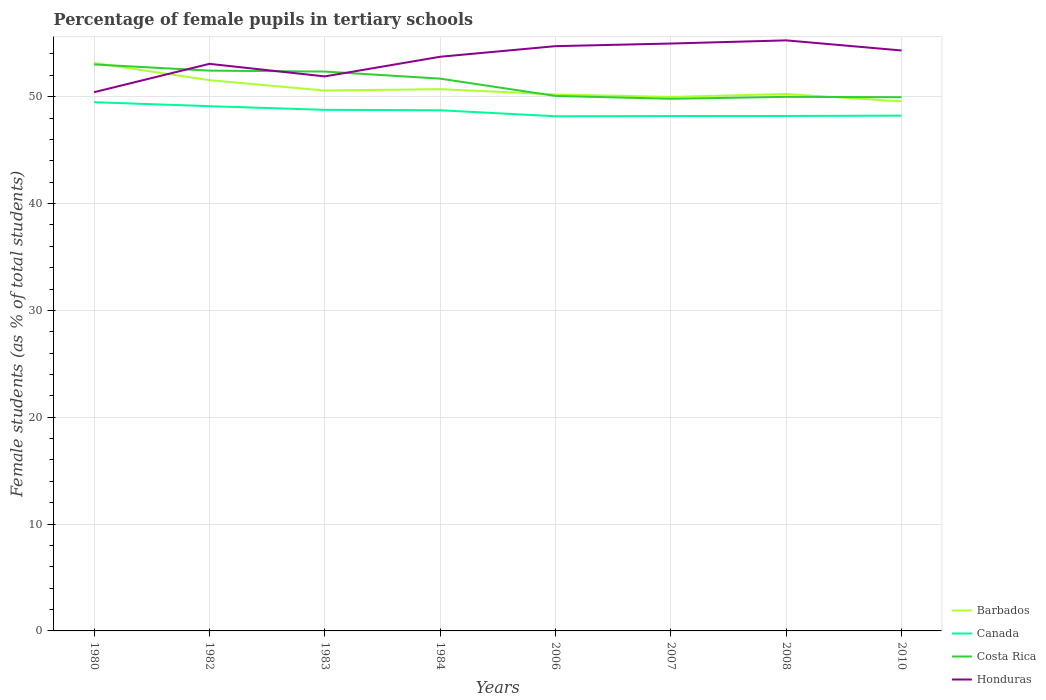How many different coloured lines are there?
Provide a short and direct response. 4. Across all years, what is the maximum percentage of female pupils in tertiary schools in Honduras?
Your answer should be compact. 50.42. In which year was the percentage of female pupils in tertiary schools in Canada maximum?
Keep it short and to the point. 2006. What is the total percentage of female pupils in tertiary schools in Honduras in the graph?
Your answer should be compact. -4.56. What is the difference between the highest and the second highest percentage of female pupils in tertiary schools in Honduras?
Ensure brevity in your answer.  4.85. What is the difference between two consecutive major ticks on the Y-axis?
Provide a succinct answer. 10. Does the graph contain any zero values?
Offer a very short reply. No. Where does the legend appear in the graph?
Make the answer very short. Bottom right. What is the title of the graph?
Your response must be concise. Percentage of female pupils in tertiary schools. What is the label or title of the Y-axis?
Give a very brief answer. Female students (as % of total students). What is the Female students (as % of total students) in Barbados in 1980?
Offer a very short reply. 53.16. What is the Female students (as % of total students) in Canada in 1980?
Provide a succinct answer. 49.48. What is the Female students (as % of total students) of Costa Rica in 1980?
Your response must be concise. 53.02. What is the Female students (as % of total students) in Honduras in 1980?
Keep it short and to the point. 50.42. What is the Female students (as % of total students) in Barbados in 1982?
Your response must be concise. 51.55. What is the Female students (as % of total students) in Canada in 1982?
Your answer should be very brief. 49.11. What is the Female students (as % of total students) of Costa Rica in 1982?
Your response must be concise. 52.44. What is the Female students (as % of total students) of Honduras in 1982?
Ensure brevity in your answer.  53.07. What is the Female students (as % of total students) in Barbados in 1983?
Give a very brief answer. 50.58. What is the Female students (as % of total students) of Canada in 1983?
Your response must be concise. 48.77. What is the Female students (as % of total students) of Costa Rica in 1983?
Offer a very short reply. 52.35. What is the Female students (as % of total students) of Honduras in 1983?
Offer a very short reply. 51.9. What is the Female students (as % of total students) in Barbados in 1984?
Your answer should be very brief. 50.71. What is the Female students (as % of total students) of Canada in 1984?
Make the answer very short. 48.73. What is the Female students (as % of total students) of Costa Rica in 1984?
Ensure brevity in your answer.  51.69. What is the Female students (as % of total students) in Honduras in 1984?
Your answer should be compact. 53.74. What is the Female students (as % of total students) of Barbados in 2006?
Your answer should be compact. 50.21. What is the Female students (as % of total students) of Canada in 2006?
Provide a succinct answer. 48.17. What is the Female students (as % of total students) of Costa Rica in 2006?
Offer a very short reply. 50.07. What is the Female students (as % of total students) of Honduras in 2006?
Provide a short and direct response. 54.73. What is the Female students (as % of total students) of Barbados in 2007?
Your answer should be compact. 49.98. What is the Female students (as % of total students) of Canada in 2007?
Give a very brief answer. 48.19. What is the Female students (as % of total students) of Costa Rica in 2007?
Offer a terse response. 49.8. What is the Female students (as % of total students) in Honduras in 2007?
Provide a short and direct response. 54.98. What is the Female students (as % of total students) in Barbados in 2008?
Keep it short and to the point. 50.25. What is the Female students (as % of total students) of Canada in 2008?
Your response must be concise. 48.2. What is the Female students (as % of total students) of Costa Rica in 2008?
Give a very brief answer. 49.99. What is the Female students (as % of total students) in Honduras in 2008?
Provide a short and direct response. 55.27. What is the Female students (as % of total students) of Barbados in 2010?
Your answer should be very brief. 49.56. What is the Female students (as % of total students) of Canada in 2010?
Provide a succinct answer. 48.23. What is the Female students (as % of total students) of Costa Rica in 2010?
Keep it short and to the point. 49.95. What is the Female students (as % of total students) in Honduras in 2010?
Ensure brevity in your answer.  54.33. Across all years, what is the maximum Female students (as % of total students) of Barbados?
Offer a terse response. 53.16. Across all years, what is the maximum Female students (as % of total students) in Canada?
Your response must be concise. 49.48. Across all years, what is the maximum Female students (as % of total students) of Costa Rica?
Your answer should be very brief. 53.02. Across all years, what is the maximum Female students (as % of total students) of Honduras?
Your answer should be very brief. 55.27. Across all years, what is the minimum Female students (as % of total students) in Barbados?
Offer a terse response. 49.56. Across all years, what is the minimum Female students (as % of total students) of Canada?
Your response must be concise. 48.17. Across all years, what is the minimum Female students (as % of total students) in Costa Rica?
Your answer should be compact. 49.8. Across all years, what is the minimum Female students (as % of total students) in Honduras?
Your response must be concise. 50.42. What is the total Female students (as % of total students) in Barbados in the graph?
Give a very brief answer. 405.99. What is the total Female students (as % of total students) of Canada in the graph?
Keep it short and to the point. 388.88. What is the total Female students (as % of total students) of Costa Rica in the graph?
Provide a succinct answer. 409.32. What is the total Female students (as % of total students) of Honduras in the graph?
Offer a terse response. 428.44. What is the difference between the Female students (as % of total students) of Barbados in 1980 and that in 1982?
Give a very brief answer. 1.61. What is the difference between the Female students (as % of total students) in Canada in 1980 and that in 1982?
Your response must be concise. 0.37. What is the difference between the Female students (as % of total students) in Costa Rica in 1980 and that in 1982?
Offer a terse response. 0.58. What is the difference between the Female students (as % of total students) in Honduras in 1980 and that in 1982?
Your answer should be compact. -2.65. What is the difference between the Female students (as % of total students) in Barbados in 1980 and that in 1983?
Offer a terse response. 2.58. What is the difference between the Female students (as % of total students) of Canada in 1980 and that in 1983?
Your answer should be very brief. 0.71. What is the difference between the Female students (as % of total students) in Costa Rica in 1980 and that in 1983?
Offer a very short reply. 0.67. What is the difference between the Female students (as % of total students) in Honduras in 1980 and that in 1983?
Your answer should be very brief. -1.48. What is the difference between the Female students (as % of total students) of Barbados in 1980 and that in 1984?
Provide a succinct answer. 2.45. What is the difference between the Female students (as % of total students) of Canada in 1980 and that in 1984?
Make the answer very short. 0.76. What is the difference between the Female students (as % of total students) of Costa Rica in 1980 and that in 1984?
Your answer should be compact. 1.33. What is the difference between the Female students (as % of total students) in Honduras in 1980 and that in 1984?
Offer a very short reply. -3.32. What is the difference between the Female students (as % of total students) of Barbados in 1980 and that in 2006?
Make the answer very short. 2.95. What is the difference between the Female students (as % of total students) in Canada in 1980 and that in 2006?
Your response must be concise. 1.32. What is the difference between the Female students (as % of total students) of Costa Rica in 1980 and that in 2006?
Offer a very short reply. 2.95. What is the difference between the Female students (as % of total students) of Honduras in 1980 and that in 2006?
Your response must be concise. -4.31. What is the difference between the Female students (as % of total students) of Barbados in 1980 and that in 2007?
Your response must be concise. 3.18. What is the difference between the Female students (as % of total students) in Canada in 1980 and that in 2007?
Make the answer very short. 1.3. What is the difference between the Female students (as % of total students) of Costa Rica in 1980 and that in 2007?
Ensure brevity in your answer.  3.21. What is the difference between the Female students (as % of total students) in Honduras in 1980 and that in 2007?
Provide a short and direct response. -4.56. What is the difference between the Female students (as % of total students) in Barbados in 1980 and that in 2008?
Provide a succinct answer. 2.9. What is the difference between the Female students (as % of total students) of Canada in 1980 and that in 2008?
Your answer should be very brief. 1.29. What is the difference between the Female students (as % of total students) of Costa Rica in 1980 and that in 2008?
Provide a succinct answer. 3.03. What is the difference between the Female students (as % of total students) of Honduras in 1980 and that in 2008?
Keep it short and to the point. -4.85. What is the difference between the Female students (as % of total students) of Barbados in 1980 and that in 2010?
Your answer should be very brief. 3.59. What is the difference between the Female students (as % of total students) in Canada in 1980 and that in 2010?
Your answer should be compact. 1.26. What is the difference between the Female students (as % of total students) in Costa Rica in 1980 and that in 2010?
Ensure brevity in your answer.  3.07. What is the difference between the Female students (as % of total students) in Honduras in 1980 and that in 2010?
Offer a terse response. -3.9. What is the difference between the Female students (as % of total students) of Canada in 1982 and that in 1983?
Your answer should be very brief. 0.34. What is the difference between the Female students (as % of total students) in Costa Rica in 1982 and that in 1983?
Offer a terse response. 0.09. What is the difference between the Female students (as % of total students) in Honduras in 1982 and that in 1983?
Provide a short and direct response. 1.18. What is the difference between the Female students (as % of total students) of Barbados in 1982 and that in 1984?
Your answer should be compact. 0.84. What is the difference between the Female students (as % of total students) of Canada in 1982 and that in 1984?
Offer a terse response. 0.38. What is the difference between the Female students (as % of total students) in Costa Rica in 1982 and that in 1984?
Offer a terse response. 0.75. What is the difference between the Female students (as % of total students) of Honduras in 1982 and that in 1984?
Offer a very short reply. -0.66. What is the difference between the Female students (as % of total students) in Barbados in 1982 and that in 2006?
Your answer should be compact. 1.34. What is the difference between the Female students (as % of total students) of Canada in 1982 and that in 2006?
Make the answer very short. 0.94. What is the difference between the Female students (as % of total students) of Costa Rica in 1982 and that in 2006?
Your answer should be compact. 2.37. What is the difference between the Female students (as % of total students) in Honduras in 1982 and that in 2006?
Keep it short and to the point. -1.66. What is the difference between the Female students (as % of total students) in Barbados in 1982 and that in 2007?
Ensure brevity in your answer.  1.57. What is the difference between the Female students (as % of total students) of Canada in 1982 and that in 2007?
Your answer should be compact. 0.92. What is the difference between the Female students (as % of total students) of Costa Rica in 1982 and that in 2007?
Your response must be concise. 2.64. What is the difference between the Female students (as % of total students) of Honduras in 1982 and that in 2007?
Ensure brevity in your answer.  -1.9. What is the difference between the Female students (as % of total students) in Barbados in 1982 and that in 2008?
Offer a terse response. 1.3. What is the difference between the Female students (as % of total students) of Canada in 1982 and that in 2008?
Offer a very short reply. 0.91. What is the difference between the Female students (as % of total students) in Costa Rica in 1982 and that in 2008?
Your answer should be very brief. 2.45. What is the difference between the Female students (as % of total students) of Honduras in 1982 and that in 2008?
Offer a very short reply. -2.2. What is the difference between the Female students (as % of total students) in Barbados in 1982 and that in 2010?
Make the answer very short. 1.99. What is the difference between the Female students (as % of total students) of Canada in 1982 and that in 2010?
Offer a terse response. 0.88. What is the difference between the Female students (as % of total students) of Costa Rica in 1982 and that in 2010?
Provide a short and direct response. 2.49. What is the difference between the Female students (as % of total students) of Honduras in 1982 and that in 2010?
Your answer should be compact. -1.25. What is the difference between the Female students (as % of total students) of Barbados in 1983 and that in 1984?
Your answer should be compact. -0.13. What is the difference between the Female students (as % of total students) of Canada in 1983 and that in 1984?
Your response must be concise. 0.04. What is the difference between the Female students (as % of total students) in Costa Rica in 1983 and that in 1984?
Give a very brief answer. 0.66. What is the difference between the Female students (as % of total students) in Honduras in 1983 and that in 1984?
Provide a short and direct response. -1.84. What is the difference between the Female students (as % of total students) in Barbados in 1983 and that in 2006?
Your answer should be compact. 0.37. What is the difference between the Female students (as % of total students) of Canada in 1983 and that in 2006?
Make the answer very short. 0.6. What is the difference between the Female students (as % of total students) of Costa Rica in 1983 and that in 2006?
Provide a short and direct response. 2.28. What is the difference between the Female students (as % of total students) of Honduras in 1983 and that in 2006?
Provide a succinct answer. -2.83. What is the difference between the Female students (as % of total students) in Barbados in 1983 and that in 2007?
Ensure brevity in your answer.  0.6. What is the difference between the Female students (as % of total students) of Canada in 1983 and that in 2007?
Offer a terse response. 0.58. What is the difference between the Female students (as % of total students) in Costa Rica in 1983 and that in 2007?
Keep it short and to the point. 2.55. What is the difference between the Female students (as % of total students) in Honduras in 1983 and that in 2007?
Make the answer very short. -3.08. What is the difference between the Female students (as % of total students) of Barbados in 1983 and that in 2008?
Ensure brevity in your answer.  0.32. What is the difference between the Female students (as % of total students) of Canada in 1983 and that in 2008?
Provide a succinct answer. 0.57. What is the difference between the Female students (as % of total students) in Costa Rica in 1983 and that in 2008?
Give a very brief answer. 2.37. What is the difference between the Female students (as % of total students) of Honduras in 1983 and that in 2008?
Offer a very short reply. -3.37. What is the difference between the Female students (as % of total students) of Barbados in 1983 and that in 2010?
Your response must be concise. 1.01. What is the difference between the Female students (as % of total students) in Canada in 1983 and that in 2010?
Provide a short and direct response. 0.54. What is the difference between the Female students (as % of total students) in Costa Rica in 1983 and that in 2010?
Your answer should be very brief. 2.4. What is the difference between the Female students (as % of total students) of Honduras in 1983 and that in 2010?
Give a very brief answer. -2.43. What is the difference between the Female students (as % of total students) of Barbados in 1984 and that in 2006?
Ensure brevity in your answer.  0.5. What is the difference between the Female students (as % of total students) in Canada in 1984 and that in 2006?
Keep it short and to the point. 0.56. What is the difference between the Female students (as % of total students) of Costa Rica in 1984 and that in 2006?
Your response must be concise. 1.62. What is the difference between the Female students (as % of total students) in Honduras in 1984 and that in 2006?
Ensure brevity in your answer.  -0.99. What is the difference between the Female students (as % of total students) in Barbados in 1984 and that in 2007?
Your response must be concise. 0.73. What is the difference between the Female students (as % of total students) in Canada in 1984 and that in 2007?
Provide a succinct answer. 0.54. What is the difference between the Female students (as % of total students) of Costa Rica in 1984 and that in 2007?
Offer a terse response. 1.89. What is the difference between the Female students (as % of total students) in Honduras in 1984 and that in 2007?
Provide a short and direct response. -1.24. What is the difference between the Female students (as % of total students) in Barbados in 1984 and that in 2008?
Your answer should be very brief. 0.45. What is the difference between the Female students (as % of total students) in Canada in 1984 and that in 2008?
Make the answer very short. 0.53. What is the difference between the Female students (as % of total students) in Costa Rica in 1984 and that in 2008?
Give a very brief answer. 1.7. What is the difference between the Female students (as % of total students) of Honduras in 1984 and that in 2008?
Keep it short and to the point. -1.53. What is the difference between the Female students (as % of total students) in Barbados in 1984 and that in 2010?
Provide a succinct answer. 1.14. What is the difference between the Female students (as % of total students) in Canada in 1984 and that in 2010?
Provide a short and direct response. 0.5. What is the difference between the Female students (as % of total students) in Costa Rica in 1984 and that in 2010?
Your answer should be very brief. 1.74. What is the difference between the Female students (as % of total students) in Honduras in 1984 and that in 2010?
Your response must be concise. -0.59. What is the difference between the Female students (as % of total students) in Barbados in 2006 and that in 2007?
Keep it short and to the point. 0.23. What is the difference between the Female students (as % of total students) of Canada in 2006 and that in 2007?
Offer a very short reply. -0.02. What is the difference between the Female students (as % of total students) in Costa Rica in 2006 and that in 2007?
Your answer should be very brief. 0.27. What is the difference between the Female students (as % of total students) in Honduras in 2006 and that in 2007?
Give a very brief answer. -0.25. What is the difference between the Female students (as % of total students) of Barbados in 2006 and that in 2008?
Your response must be concise. -0.04. What is the difference between the Female students (as % of total students) of Canada in 2006 and that in 2008?
Give a very brief answer. -0.03. What is the difference between the Female students (as % of total students) in Costa Rica in 2006 and that in 2008?
Provide a succinct answer. 0.09. What is the difference between the Female students (as % of total students) in Honduras in 2006 and that in 2008?
Provide a succinct answer. -0.54. What is the difference between the Female students (as % of total students) of Barbados in 2006 and that in 2010?
Keep it short and to the point. 0.65. What is the difference between the Female students (as % of total students) of Canada in 2006 and that in 2010?
Your answer should be very brief. -0.06. What is the difference between the Female students (as % of total students) in Costa Rica in 2006 and that in 2010?
Keep it short and to the point. 0.12. What is the difference between the Female students (as % of total students) in Honduras in 2006 and that in 2010?
Provide a short and direct response. 0.4. What is the difference between the Female students (as % of total students) of Barbados in 2007 and that in 2008?
Keep it short and to the point. -0.28. What is the difference between the Female students (as % of total students) in Canada in 2007 and that in 2008?
Offer a terse response. -0.01. What is the difference between the Female students (as % of total students) of Costa Rica in 2007 and that in 2008?
Provide a short and direct response. -0.18. What is the difference between the Female students (as % of total students) of Honduras in 2007 and that in 2008?
Provide a short and direct response. -0.3. What is the difference between the Female students (as % of total students) of Barbados in 2007 and that in 2010?
Offer a very short reply. 0.42. What is the difference between the Female students (as % of total students) of Canada in 2007 and that in 2010?
Your answer should be compact. -0.04. What is the difference between the Female students (as % of total students) in Costa Rica in 2007 and that in 2010?
Give a very brief answer. -0.15. What is the difference between the Female students (as % of total students) of Honduras in 2007 and that in 2010?
Your response must be concise. 0.65. What is the difference between the Female students (as % of total students) of Barbados in 2008 and that in 2010?
Provide a short and direct response. 0.69. What is the difference between the Female students (as % of total students) of Canada in 2008 and that in 2010?
Make the answer very short. -0.03. What is the difference between the Female students (as % of total students) of Costa Rica in 2008 and that in 2010?
Offer a very short reply. 0.03. What is the difference between the Female students (as % of total students) in Honduras in 2008 and that in 2010?
Your answer should be very brief. 0.95. What is the difference between the Female students (as % of total students) in Barbados in 1980 and the Female students (as % of total students) in Canada in 1982?
Ensure brevity in your answer.  4.04. What is the difference between the Female students (as % of total students) in Barbados in 1980 and the Female students (as % of total students) in Costa Rica in 1982?
Ensure brevity in your answer.  0.72. What is the difference between the Female students (as % of total students) in Barbados in 1980 and the Female students (as % of total students) in Honduras in 1982?
Make the answer very short. 0.08. What is the difference between the Female students (as % of total students) of Canada in 1980 and the Female students (as % of total students) of Costa Rica in 1982?
Offer a very short reply. -2.96. What is the difference between the Female students (as % of total students) in Canada in 1980 and the Female students (as % of total students) in Honduras in 1982?
Ensure brevity in your answer.  -3.59. What is the difference between the Female students (as % of total students) of Costa Rica in 1980 and the Female students (as % of total students) of Honduras in 1982?
Your answer should be very brief. -0.06. What is the difference between the Female students (as % of total students) of Barbados in 1980 and the Female students (as % of total students) of Canada in 1983?
Provide a short and direct response. 4.38. What is the difference between the Female students (as % of total students) in Barbados in 1980 and the Female students (as % of total students) in Costa Rica in 1983?
Ensure brevity in your answer.  0.8. What is the difference between the Female students (as % of total students) of Barbados in 1980 and the Female students (as % of total students) of Honduras in 1983?
Make the answer very short. 1.26. What is the difference between the Female students (as % of total students) of Canada in 1980 and the Female students (as % of total students) of Costa Rica in 1983?
Provide a short and direct response. -2.87. What is the difference between the Female students (as % of total students) in Canada in 1980 and the Female students (as % of total students) in Honduras in 1983?
Your response must be concise. -2.41. What is the difference between the Female students (as % of total students) in Costa Rica in 1980 and the Female students (as % of total students) in Honduras in 1983?
Keep it short and to the point. 1.12. What is the difference between the Female students (as % of total students) in Barbados in 1980 and the Female students (as % of total students) in Canada in 1984?
Ensure brevity in your answer.  4.43. What is the difference between the Female students (as % of total students) in Barbados in 1980 and the Female students (as % of total students) in Costa Rica in 1984?
Give a very brief answer. 1.47. What is the difference between the Female students (as % of total students) in Barbados in 1980 and the Female students (as % of total students) in Honduras in 1984?
Provide a succinct answer. -0.58. What is the difference between the Female students (as % of total students) in Canada in 1980 and the Female students (as % of total students) in Costa Rica in 1984?
Your answer should be very brief. -2.21. What is the difference between the Female students (as % of total students) in Canada in 1980 and the Female students (as % of total students) in Honduras in 1984?
Ensure brevity in your answer.  -4.25. What is the difference between the Female students (as % of total students) of Costa Rica in 1980 and the Female students (as % of total students) of Honduras in 1984?
Offer a very short reply. -0.72. What is the difference between the Female students (as % of total students) of Barbados in 1980 and the Female students (as % of total students) of Canada in 2006?
Your answer should be compact. 4.99. What is the difference between the Female students (as % of total students) of Barbados in 1980 and the Female students (as % of total students) of Costa Rica in 2006?
Your answer should be compact. 3.08. What is the difference between the Female students (as % of total students) of Barbados in 1980 and the Female students (as % of total students) of Honduras in 2006?
Make the answer very short. -1.57. What is the difference between the Female students (as % of total students) in Canada in 1980 and the Female students (as % of total students) in Costa Rica in 2006?
Offer a terse response. -0.59. What is the difference between the Female students (as % of total students) of Canada in 1980 and the Female students (as % of total students) of Honduras in 2006?
Offer a very short reply. -5.25. What is the difference between the Female students (as % of total students) in Costa Rica in 1980 and the Female students (as % of total students) in Honduras in 2006?
Make the answer very short. -1.71. What is the difference between the Female students (as % of total students) of Barbados in 1980 and the Female students (as % of total students) of Canada in 2007?
Offer a very short reply. 4.97. What is the difference between the Female students (as % of total students) of Barbados in 1980 and the Female students (as % of total students) of Costa Rica in 2007?
Make the answer very short. 3.35. What is the difference between the Female students (as % of total students) of Barbados in 1980 and the Female students (as % of total students) of Honduras in 2007?
Provide a short and direct response. -1.82. What is the difference between the Female students (as % of total students) of Canada in 1980 and the Female students (as % of total students) of Costa Rica in 2007?
Make the answer very short. -0.32. What is the difference between the Female students (as % of total students) in Canada in 1980 and the Female students (as % of total students) in Honduras in 2007?
Your answer should be compact. -5.49. What is the difference between the Female students (as % of total students) in Costa Rica in 1980 and the Female students (as % of total students) in Honduras in 2007?
Your response must be concise. -1.96. What is the difference between the Female students (as % of total students) in Barbados in 1980 and the Female students (as % of total students) in Canada in 2008?
Offer a terse response. 4.96. What is the difference between the Female students (as % of total students) of Barbados in 1980 and the Female students (as % of total students) of Costa Rica in 2008?
Make the answer very short. 3.17. What is the difference between the Female students (as % of total students) of Barbados in 1980 and the Female students (as % of total students) of Honduras in 2008?
Offer a terse response. -2.12. What is the difference between the Female students (as % of total students) of Canada in 1980 and the Female students (as % of total students) of Costa Rica in 2008?
Ensure brevity in your answer.  -0.5. What is the difference between the Female students (as % of total students) of Canada in 1980 and the Female students (as % of total students) of Honduras in 2008?
Make the answer very short. -5.79. What is the difference between the Female students (as % of total students) of Costa Rica in 1980 and the Female students (as % of total students) of Honduras in 2008?
Provide a short and direct response. -2.25. What is the difference between the Female students (as % of total students) of Barbados in 1980 and the Female students (as % of total students) of Canada in 2010?
Offer a very short reply. 4.93. What is the difference between the Female students (as % of total students) in Barbados in 1980 and the Female students (as % of total students) in Costa Rica in 2010?
Offer a terse response. 3.2. What is the difference between the Female students (as % of total students) in Barbados in 1980 and the Female students (as % of total students) in Honduras in 2010?
Make the answer very short. -1.17. What is the difference between the Female students (as % of total students) of Canada in 1980 and the Female students (as % of total students) of Costa Rica in 2010?
Your answer should be compact. -0.47. What is the difference between the Female students (as % of total students) in Canada in 1980 and the Female students (as % of total students) in Honduras in 2010?
Offer a terse response. -4.84. What is the difference between the Female students (as % of total students) in Costa Rica in 1980 and the Female students (as % of total students) in Honduras in 2010?
Your answer should be very brief. -1.31. What is the difference between the Female students (as % of total students) in Barbados in 1982 and the Female students (as % of total students) in Canada in 1983?
Your response must be concise. 2.78. What is the difference between the Female students (as % of total students) of Barbados in 1982 and the Female students (as % of total students) of Costa Rica in 1983?
Provide a succinct answer. -0.8. What is the difference between the Female students (as % of total students) in Barbados in 1982 and the Female students (as % of total students) in Honduras in 1983?
Offer a very short reply. -0.35. What is the difference between the Female students (as % of total students) of Canada in 1982 and the Female students (as % of total students) of Costa Rica in 1983?
Make the answer very short. -3.24. What is the difference between the Female students (as % of total students) in Canada in 1982 and the Female students (as % of total students) in Honduras in 1983?
Provide a succinct answer. -2.79. What is the difference between the Female students (as % of total students) of Costa Rica in 1982 and the Female students (as % of total students) of Honduras in 1983?
Make the answer very short. 0.54. What is the difference between the Female students (as % of total students) of Barbados in 1982 and the Female students (as % of total students) of Canada in 1984?
Provide a succinct answer. 2.82. What is the difference between the Female students (as % of total students) in Barbados in 1982 and the Female students (as % of total students) in Costa Rica in 1984?
Your response must be concise. -0.14. What is the difference between the Female students (as % of total students) in Barbados in 1982 and the Female students (as % of total students) in Honduras in 1984?
Keep it short and to the point. -2.19. What is the difference between the Female students (as % of total students) in Canada in 1982 and the Female students (as % of total students) in Costa Rica in 1984?
Ensure brevity in your answer.  -2.58. What is the difference between the Female students (as % of total students) of Canada in 1982 and the Female students (as % of total students) of Honduras in 1984?
Provide a succinct answer. -4.63. What is the difference between the Female students (as % of total students) in Costa Rica in 1982 and the Female students (as % of total students) in Honduras in 1984?
Give a very brief answer. -1.3. What is the difference between the Female students (as % of total students) in Barbados in 1982 and the Female students (as % of total students) in Canada in 2006?
Your answer should be very brief. 3.38. What is the difference between the Female students (as % of total students) in Barbados in 1982 and the Female students (as % of total students) in Costa Rica in 2006?
Your response must be concise. 1.48. What is the difference between the Female students (as % of total students) of Barbados in 1982 and the Female students (as % of total students) of Honduras in 2006?
Your answer should be compact. -3.18. What is the difference between the Female students (as % of total students) in Canada in 1982 and the Female students (as % of total students) in Costa Rica in 2006?
Your answer should be very brief. -0.96. What is the difference between the Female students (as % of total students) of Canada in 1982 and the Female students (as % of total students) of Honduras in 2006?
Make the answer very short. -5.62. What is the difference between the Female students (as % of total students) in Costa Rica in 1982 and the Female students (as % of total students) in Honduras in 2006?
Give a very brief answer. -2.29. What is the difference between the Female students (as % of total students) of Barbados in 1982 and the Female students (as % of total students) of Canada in 2007?
Make the answer very short. 3.36. What is the difference between the Female students (as % of total students) in Barbados in 1982 and the Female students (as % of total students) in Costa Rica in 2007?
Make the answer very short. 1.74. What is the difference between the Female students (as % of total students) in Barbados in 1982 and the Female students (as % of total students) in Honduras in 2007?
Give a very brief answer. -3.43. What is the difference between the Female students (as % of total students) in Canada in 1982 and the Female students (as % of total students) in Costa Rica in 2007?
Give a very brief answer. -0.69. What is the difference between the Female students (as % of total students) in Canada in 1982 and the Female students (as % of total students) in Honduras in 2007?
Offer a terse response. -5.87. What is the difference between the Female students (as % of total students) of Costa Rica in 1982 and the Female students (as % of total students) of Honduras in 2007?
Provide a short and direct response. -2.54. What is the difference between the Female students (as % of total students) in Barbados in 1982 and the Female students (as % of total students) in Canada in 2008?
Give a very brief answer. 3.35. What is the difference between the Female students (as % of total students) in Barbados in 1982 and the Female students (as % of total students) in Costa Rica in 2008?
Provide a succinct answer. 1.56. What is the difference between the Female students (as % of total students) of Barbados in 1982 and the Female students (as % of total students) of Honduras in 2008?
Offer a terse response. -3.72. What is the difference between the Female students (as % of total students) of Canada in 1982 and the Female students (as % of total students) of Costa Rica in 2008?
Offer a very short reply. -0.87. What is the difference between the Female students (as % of total students) of Canada in 1982 and the Female students (as % of total students) of Honduras in 2008?
Offer a terse response. -6.16. What is the difference between the Female students (as % of total students) of Costa Rica in 1982 and the Female students (as % of total students) of Honduras in 2008?
Offer a terse response. -2.83. What is the difference between the Female students (as % of total students) of Barbados in 1982 and the Female students (as % of total students) of Canada in 2010?
Provide a succinct answer. 3.32. What is the difference between the Female students (as % of total students) of Barbados in 1982 and the Female students (as % of total students) of Costa Rica in 2010?
Ensure brevity in your answer.  1.6. What is the difference between the Female students (as % of total students) in Barbados in 1982 and the Female students (as % of total students) in Honduras in 2010?
Make the answer very short. -2.78. What is the difference between the Female students (as % of total students) of Canada in 1982 and the Female students (as % of total students) of Costa Rica in 2010?
Give a very brief answer. -0.84. What is the difference between the Female students (as % of total students) of Canada in 1982 and the Female students (as % of total students) of Honduras in 2010?
Ensure brevity in your answer.  -5.21. What is the difference between the Female students (as % of total students) of Costa Rica in 1982 and the Female students (as % of total students) of Honduras in 2010?
Make the answer very short. -1.88. What is the difference between the Female students (as % of total students) of Barbados in 1983 and the Female students (as % of total students) of Canada in 1984?
Provide a short and direct response. 1.85. What is the difference between the Female students (as % of total students) in Barbados in 1983 and the Female students (as % of total students) in Costa Rica in 1984?
Ensure brevity in your answer.  -1.12. What is the difference between the Female students (as % of total students) of Barbados in 1983 and the Female students (as % of total students) of Honduras in 1984?
Your response must be concise. -3.16. What is the difference between the Female students (as % of total students) in Canada in 1983 and the Female students (as % of total students) in Costa Rica in 1984?
Make the answer very short. -2.92. What is the difference between the Female students (as % of total students) in Canada in 1983 and the Female students (as % of total students) in Honduras in 1984?
Your answer should be very brief. -4.97. What is the difference between the Female students (as % of total students) in Costa Rica in 1983 and the Female students (as % of total students) in Honduras in 1984?
Provide a succinct answer. -1.39. What is the difference between the Female students (as % of total students) of Barbados in 1983 and the Female students (as % of total students) of Canada in 2006?
Your answer should be very brief. 2.41. What is the difference between the Female students (as % of total students) of Barbados in 1983 and the Female students (as % of total students) of Costa Rica in 2006?
Your answer should be compact. 0.5. What is the difference between the Female students (as % of total students) of Barbados in 1983 and the Female students (as % of total students) of Honduras in 2006?
Provide a succinct answer. -4.16. What is the difference between the Female students (as % of total students) in Canada in 1983 and the Female students (as % of total students) in Costa Rica in 2006?
Provide a succinct answer. -1.3. What is the difference between the Female students (as % of total students) in Canada in 1983 and the Female students (as % of total students) in Honduras in 2006?
Make the answer very short. -5.96. What is the difference between the Female students (as % of total students) of Costa Rica in 1983 and the Female students (as % of total students) of Honduras in 2006?
Ensure brevity in your answer.  -2.38. What is the difference between the Female students (as % of total students) in Barbados in 1983 and the Female students (as % of total students) in Canada in 2007?
Your response must be concise. 2.39. What is the difference between the Female students (as % of total students) of Barbados in 1983 and the Female students (as % of total students) of Costa Rica in 2007?
Your answer should be compact. 0.77. What is the difference between the Female students (as % of total students) of Barbados in 1983 and the Female students (as % of total students) of Honduras in 2007?
Your answer should be compact. -4.4. What is the difference between the Female students (as % of total students) in Canada in 1983 and the Female students (as % of total students) in Costa Rica in 2007?
Keep it short and to the point. -1.03. What is the difference between the Female students (as % of total students) in Canada in 1983 and the Female students (as % of total students) in Honduras in 2007?
Your response must be concise. -6.21. What is the difference between the Female students (as % of total students) in Costa Rica in 1983 and the Female students (as % of total students) in Honduras in 2007?
Offer a very short reply. -2.62. What is the difference between the Female students (as % of total students) of Barbados in 1983 and the Female students (as % of total students) of Canada in 2008?
Make the answer very short. 2.38. What is the difference between the Female students (as % of total students) in Barbados in 1983 and the Female students (as % of total students) in Costa Rica in 2008?
Offer a terse response. 0.59. What is the difference between the Female students (as % of total students) in Barbados in 1983 and the Female students (as % of total students) in Honduras in 2008?
Offer a very short reply. -4.7. What is the difference between the Female students (as % of total students) in Canada in 1983 and the Female students (as % of total students) in Costa Rica in 2008?
Provide a short and direct response. -1.22. What is the difference between the Female students (as % of total students) in Canada in 1983 and the Female students (as % of total students) in Honduras in 2008?
Provide a short and direct response. -6.5. What is the difference between the Female students (as % of total students) in Costa Rica in 1983 and the Female students (as % of total students) in Honduras in 2008?
Offer a terse response. -2.92. What is the difference between the Female students (as % of total students) in Barbados in 1983 and the Female students (as % of total students) in Canada in 2010?
Keep it short and to the point. 2.35. What is the difference between the Female students (as % of total students) of Barbados in 1983 and the Female students (as % of total students) of Costa Rica in 2010?
Provide a short and direct response. 0.62. What is the difference between the Female students (as % of total students) in Barbados in 1983 and the Female students (as % of total students) in Honduras in 2010?
Make the answer very short. -3.75. What is the difference between the Female students (as % of total students) of Canada in 1983 and the Female students (as % of total students) of Costa Rica in 2010?
Offer a very short reply. -1.18. What is the difference between the Female students (as % of total students) in Canada in 1983 and the Female students (as % of total students) in Honduras in 2010?
Your answer should be compact. -5.55. What is the difference between the Female students (as % of total students) of Costa Rica in 1983 and the Female students (as % of total students) of Honduras in 2010?
Keep it short and to the point. -1.97. What is the difference between the Female students (as % of total students) in Barbados in 1984 and the Female students (as % of total students) in Canada in 2006?
Make the answer very short. 2.54. What is the difference between the Female students (as % of total students) of Barbados in 1984 and the Female students (as % of total students) of Costa Rica in 2006?
Your response must be concise. 0.63. What is the difference between the Female students (as % of total students) in Barbados in 1984 and the Female students (as % of total students) in Honduras in 2006?
Your response must be concise. -4.03. What is the difference between the Female students (as % of total students) in Canada in 1984 and the Female students (as % of total students) in Costa Rica in 2006?
Provide a short and direct response. -1.34. What is the difference between the Female students (as % of total students) in Canada in 1984 and the Female students (as % of total students) in Honduras in 2006?
Offer a terse response. -6. What is the difference between the Female students (as % of total students) in Costa Rica in 1984 and the Female students (as % of total students) in Honduras in 2006?
Provide a succinct answer. -3.04. What is the difference between the Female students (as % of total students) of Barbados in 1984 and the Female students (as % of total students) of Canada in 2007?
Make the answer very short. 2.52. What is the difference between the Female students (as % of total students) of Barbados in 1984 and the Female students (as % of total students) of Costa Rica in 2007?
Make the answer very short. 0.9. What is the difference between the Female students (as % of total students) of Barbados in 1984 and the Female students (as % of total students) of Honduras in 2007?
Offer a terse response. -4.27. What is the difference between the Female students (as % of total students) of Canada in 1984 and the Female students (as % of total students) of Costa Rica in 2007?
Make the answer very short. -1.07. What is the difference between the Female students (as % of total students) in Canada in 1984 and the Female students (as % of total students) in Honduras in 2007?
Your answer should be very brief. -6.25. What is the difference between the Female students (as % of total students) in Costa Rica in 1984 and the Female students (as % of total students) in Honduras in 2007?
Your answer should be compact. -3.29. What is the difference between the Female students (as % of total students) of Barbados in 1984 and the Female students (as % of total students) of Canada in 2008?
Your answer should be compact. 2.51. What is the difference between the Female students (as % of total students) of Barbados in 1984 and the Female students (as % of total students) of Costa Rica in 2008?
Offer a terse response. 0.72. What is the difference between the Female students (as % of total students) of Barbados in 1984 and the Female students (as % of total students) of Honduras in 2008?
Your answer should be compact. -4.57. What is the difference between the Female students (as % of total students) of Canada in 1984 and the Female students (as % of total students) of Costa Rica in 2008?
Give a very brief answer. -1.26. What is the difference between the Female students (as % of total students) in Canada in 1984 and the Female students (as % of total students) in Honduras in 2008?
Offer a terse response. -6.54. What is the difference between the Female students (as % of total students) in Costa Rica in 1984 and the Female students (as % of total students) in Honduras in 2008?
Provide a short and direct response. -3.58. What is the difference between the Female students (as % of total students) in Barbados in 1984 and the Female students (as % of total students) in Canada in 2010?
Keep it short and to the point. 2.48. What is the difference between the Female students (as % of total students) of Barbados in 1984 and the Female students (as % of total students) of Costa Rica in 2010?
Ensure brevity in your answer.  0.75. What is the difference between the Female students (as % of total students) of Barbados in 1984 and the Female students (as % of total students) of Honduras in 2010?
Give a very brief answer. -3.62. What is the difference between the Female students (as % of total students) of Canada in 1984 and the Female students (as % of total students) of Costa Rica in 2010?
Make the answer very short. -1.22. What is the difference between the Female students (as % of total students) in Canada in 1984 and the Female students (as % of total students) in Honduras in 2010?
Your answer should be very brief. -5.6. What is the difference between the Female students (as % of total students) in Costa Rica in 1984 and the Female students (as % of total students) in Honduras in 2010?
Your answer should be compact. -2.64. What is the difference between the Female students (as % of total students) of Barbados in 2006 and the Female students (as % of total students) of Canada in 2007?
Make the answer very short. 2.02. What is the difference between the Female students (as % of total students) of Barbados in 2006 and the Female students (as % of total students) of Costa Rica in 2007?
Keep it short and to the point. 0.4. What is the difference between the Female students (as % of total students) of Barbados in 2006 and the Female students (as % of total students) of Honduras in 2007?
Your answer should be very brief. -4.77. What is the difference between the Female students (as % of total students) of Canada in 2006 and the Female students (as % of total students) of Costa Rica in 2007?
Offer a terse response. -1.64. What is the difference between the Female students (as % of total students) in Canada in 2006 and the Female students (as % of total students) in Honduras in 2007?
Offer a terse response. -6.81. What is the difference between the Female students (as % of total students) of Costa Rica in 2006 and the Female students (as % of total students) of Honduras in 2007?
Your response must be concise. -4.9. What is the difference between the Female students (as % of total students) in Barbados in 2006 and the Female students (as % of total students) in Canada in 2008?
Your answer should be very brief. 2.01. What is the difference between the Female students (as % of total students) in Barbados in 2006 and the Female students (as % of total students) in Costa Rica in 2008?
Provide a short and direct response. 0.22. What is the difference between the Female students (as % of total students) of Barbados in 2006 and the Female students (as % of total students) of Honduras in 2008?
Give a very brief answer. -5.06. What is the difference between the Female students (as % of total students) in Canada in 2006 and the Female students (as % of total students) in Costa Rica in 2008?
Make the answer very short. -1.82. What is the difference between the Female students (as % of total students) of Canada in 2006 and the Female students (as % of total students) of Honduras in 2008?
Your answer should be very brief. -7.1. What is the difference between the Female students (as % of total students) in Costa Rica in 2006 and the Female students (as % of total students) in Honduras in 2008?
Your answer should be very brief. -5.2. What is the difference between the Female students (as % of total students) in Barbados in 2006 and the Female students (as % of total students) in Canada in 2010?
Your answer should be compact. 1.98. What is the difference between the Female students (as % of total students) of Barbados in 2006 and the Female students (as % of total students) of Costa Rica in 2010?
Your response must be concise. 0.26. What is the difference between the Female students (as % of total students) in Barbados in 2006 and the Female students (as % of total students) in Honduras in 2010?
Offer a terse response. -4.12. What is the difference between the Female students (as % of total students) of Canada in 2006 and the Female students (as % of total students) of Costa Rica in 2010?
Your answer should be very brief. -1.78. What is the difference between the Female students (as % of total students) of Canada in 2006 and the Female students (as % of total students) of Honduras in 2010?
Provide a succinct answer. -6.16. What is the difference between the Female students (as % of total students) of Costa Rica in 2006 and the Female students (as % of total students) of Honduras in 2010?
Offer a very short reply. -4.25. What is the difference between the Female students (as % of total students) of Barbados in 2007 and the Female students (as % of total students) of Canada in 2008?
Give a very brief answer. 1.78. What is the difference between the Female students (as % of total students) in Barbados in 2007 and the Female students (as % of total students) in Costa Rica in 2008?
Keep it short and to the point. -0.01. What is the difference between the Female students (as % of total students) of Barbados in 2007 and the Female students (as % of total students) of Honduras in 2008?
Keep it short and to the point. -5.29. What is the difference between the Female students (as % of total students) of Canada in 2007 and the Female students (as % of total students) of Costa Rica in 2008?
Offer a terse response. -1.8. What is the difference between the Female students (as % of total students) of Canada in 2007 and the Female students (as % of total students) of Honduras in 2008?
Offer a very short reply. -7.08. What is the difference between the Female students (as % of total students) of Costa Rica in 2007 and the Female students (as % of total students) of Honduras in 2008?
Ensure brevity in your answer.  -5.47. What is the difference between the Female students (as % of total students) of Barbados in 2007 and the Female students (as % of total students) of Canada in 2010?
Your answer should be very brief. 1.75. What is the difference between the Female students (as % of total students) in Barbados in 2007 and the Female students (as % of total students) in Costa Rica in 2010?
Offer a terse response. 0.03. What is the difference between the Female students (as % of total students) of Barbados in 2007 and the Female students (as % of total students) of Honduras in 2010?
Your response must be concise. -4.35. What is the difference between the Female students (as % of total students) in Canada in 2007 and the Female students (as % of total students) in Costa Rica in 2010?
Offer a terse response. -1.76. What is the difference between the Female students (as % of total students) of Canada in 2007 and the Female students (as % of total students) of Honduras in 2010?
Give a very brief answer. -6.14. What is the difference between the Female students (as % of total students) of Costa Rica in 2007 and the Female students (as % of total students) of Honduras in 2010?
Offer a very short reply. -4.52. What is the difference between the Female students (as % of total students) of Barbados in 2008 and the Female students (as % of total students) of Canada in 2010?
Provide a succinct answer. 2.03. What is the difference between the Female students (as % of total students) in Barbados in 2008 and the Female students (as % of total students) in Costa Rica in 2010?
Give a very brief answer. 0.3. What is the difference between the Female students (as % of total students) of Barbados in 2008 and the Female students (as % of total students) of Honduras in 2010?
Give a very brief answer. -4.07. What is the difference between the Female students (as % of total students) of Canada in 2008 and the Female students (as % of total students) of Costa Rica in 2010?
Provide a succinct answer. -1.76. What is the difference between the Female students (as % of total students) in Canada in 2008 and the Female students (as % of total students) in Honduras in 2010?
Your response must be concise. -6.13. What is the difference between the Female students (as % of total students) of Costa Rica in 2008 and the Female students (as % of total students) of Honduras in 2010?
Your answer should be very brief. -4.34. What is the average Female students (as % of total students) of Barbados per year?
Offer a very short reply. 50.75. What is the average Female students (as % of total students) in Canada per year?
Offer a very short reply. 48.61. What is the average Female students (as % of total students) in Costa Rica per year?
Your answer should be very brief. 51.16. What is the average Female students (as % of total students) in Honduras per year?
Provide a succinct answer. 53.55. In the year 1980, what is the difference between the Female students (as % of total students) of Barbados and Female students (as % of total students) of Canada?
Your answer should be very brief. 3.67. In the year 1980, what is the difference between the Female students (as % of total students) of Barbados and Female students (as % of total students) of Costa Rica?
Make the answer very short. 0.14. In the year 1980, what is the difference between the Female students (as % of total students) of Barbados and Female students (as % of total students) of Honduras?
Keep it short and to the point. 2.74. In the year 1980, what is the difference between the Female students (as % of total students) in Canada and Female students (as % of total students) in Costa Rica?
Your answer should be compact. -3.53. In the year 1980, what is the difference between the Female students (as % of total students) of Canada and Female students (as % of total students) of Honduras?
Make the answer very short. -0.94. In the year 1980, what is the difference between the Female students (as % of total students) in Costa Rica and Female students (as % of total students) in Honduras?
Keep it short and to the point. 2.6. In the year 1982, what is the difference between the Female students (as % of total students) of Barbados and Female students (as % of total students) of Canada?
Keep it short and to the point. 2.44. In the year 1982, what is the difference between the Female students (as % of total students) of Barbados and Female students (as % of total students) of Costa Rica?
Provide a succinct answer. -0.89. In the year 1982, what is the difference between the Female students (as % of total students) in Barbados and Female students (as % of total students) in Honduras?
Your response must be concise. -1.53. In the year 1982, what is the difference between the Female students (as % of total students) in Canada and Female students (as % of total students) in Costa Rica?
Your answer should be very brief. -3.33. In the year 1982, what is the difference between the Female students (as % of total students) of Canada and Female students (as % of total students) of Honduras?
Ensure brevity in your answer.  -3.96. In the year 1982, what is the difference between the Female students (as % of total students) of Costa Rica and Female students (as % of total students) of Honduras?
Make the answer very short. -0.63. In the year 1983, what is the difference between the Female students (as % of total students) of Barbados and Female students (as % of total students) of Canada?
Make the answer very short. 1.8. In the year 1983, what is the difference between the Female students (as % of total students) of Barbados and Female students (as % of total students) of Costa Rica?
Provide a short and direct response. -1.78. In the year 1983, what is the difference between the Female students (as % of total students) of Barbados and Female students (as % of total students) of Honduras?
Keep it short and to the point. -1.32. In the year 1983, what is the difference between the Female students (as % of total students) in Canada and Female students (as % of total students) in Costa Rica?
Make the answer very short. -3.58. In the year 1983, what is the difference between the Female students (as % of total students) of Canada and Female students (as % of total students) of Honduras?
Ensure brevity in your answer.  -3.13. In the year 1983, what is the difference between the Female students (as % of total students) in Costa Rica and Female students (as % of total students) in Honduras?
Provide a short and direct response. 0.45. In the year 1984, what is the difference between the Female students (as % of total students) of Barbados and Female students (as % of total students) of Canada?
Ensure brevity in your answer.  1.98. In the year 1984, what is the difference between the Female students (as % of total students) of Barbados and Female students (as % of total students) of Costa Rica?
Offer a terse response. -0.99. In the year 1984, what is the difference between the Female students (as % of total students) in Barbados and Female students (as % of total students) in Honduras?
Give a very brief answer. -3.03. In the year 1984, what is the difference between the Female students (as % of total students) in Canada and Female students (as % of total students) in Costa Rica?
Your answer should be compact. -2.96. In the year 1984, what is the difference between the Female students (as % of total students) of Canada and Female students (as % of total students) of Honduras?
Your response must be concise. -5.01. In the year 1984, what is the difference between the Female students (as % of total students) of Costa Rica and Female students (as % of total students) of Honduras?
Give a very brief answer. -2.05. In the year 2006, what is the difference between the Female students (as % of total students) of Barbados and Female students (as % of total students) of Canada?
Offer a very short reply. 2.04. In the year 2006, what is the difference between the Female students (as % of total students) in Barbados and Female students (as % of total students) in Costa Rica?
Provide a short and direct response. 0.14. In the year 2006, what is the difference between the Female students (as % of total students) in Barbados and Female students (as % of total students) in Honduras?
Your response must be concise. -4.52. In the year 2006, what is the difference between the Female students (as % of total students) in Canada and Female students (as % of total students) in Costa Rica?
Offer a very short reply. -1.9. In the year 2006, what is the difference between the Female students (as % of total students) of Canada and Female students (as % of total students) of Honduras?
Provide a short and direct response. -6.56. In the year 2006, what is the difference between the Female students (as % of total students) in Costa Rica and Female students (as % of total students) in Honduras?
Offer a very short reply. -4.66. In the year 2007, what is the difference between the Female students (as % of total students) in Barbados and Female students (as % of total students) in Canada?
Provide a short and direct response. 1.79. In the year 2007, what is the difference between the Female students (as % of total students) in Barbados and Female students (as % of total students) in Costa Rica?
Make the answer very short. 0.17. In the year 2007, what is the difference between the Female students (as % of total students) in Barbados and Female students (as % of total students) in Honduras?
Your answer should be very brief. -5. In the year 2007, what is the difference between the Female students (as % of total students) of Canada and Female students (as % of total students) of Costa Rica?
Provide a short and direct response. -1.62. In the year 2007, what is the difference between the Female students (as % of total students) of Canada and Female students (as % of total students) of Honduras?
Offer a terse response. -6.79. In the year 2007, what is the difference between the Female students (as % of total students) in Costa Rica and Female students (as % of total students) in Honduras?
Your answer should be very brief. -5.17. In the year 2008, what is the difference between the Female students (as % of total students) of Barbados and Female students (as % of total students) of Canada?
Keep it short and to the point. 2.06. In the year 2008, what is the difference between the Female students (as % of total students) of Barbados and Female students (as % of total students) of Costa Rica?
Offer a very short reply. 0.27. In the year 2008, what is the difference between the Female students (as % of total students) of Barbados and Female students (as % of total students) of Honduras?
Provide a succinct answer. -5.02. In the year 2008, what is the difference between the Female students (as % of total students) in Canada and Female students (as % of total students) in Costa Rica?
Your answer should be compact. -1.79. In the year 2008, what is the difference between the Female students (as % of total students) of Canada and Female students (as % of total students) of Honduras?
Make the answer very short. -7.08. In the year 2008, what is the difference between the Female students (as % of total students) in Costa Rica and Female students (as % of total students) in Honduras?
Your answer should be very brief. -5.29. In the year 2010, what is the difference between the Female students (as % of total students) in Barbados and Female students (as % of total students) in Canada?
Ensure brevity in your answer.  1.33. In the year 2010, what is the difference between the Female students (as % of total students) in Barbados and Female students (as % of total students) in Costa Rica?
Your response must be concise. -0.39. In the year 2010, what is the difference between the Female students (as % of total students) of Barbados and Female students (as % of total students) of Honduras?
Offer a terse response. -4.76. In the year 2010, what is the difference between the Female students (as % of total students) of Canada and Female students (as % of total students) of Costa Rica?
Give a very brief answer. -1.72. In the year 2010, what is the difference between the Female students (as % of total students) of Canada and Female students (as % of total students) of Honduras?
Ensure brevity in your answer.  -6.1. In the year 2010, what is the difference between the Female students (as % of total students) of Costa Rica and Female students (as % of total students) of Honduras?
Offer a very short reply. -4.37. What is the ratio of the Female students (as % of total students) in Barbados in 1980 to that in 1982?
Offer a terse response. 1.03. What is the ratio of the Female students (as % of total students) of Canada in 1980 to that in 1982?
Ensure brevity in your answer.  1.01. What is the ratio of the Female students (as % of total students) in Honduras in 1980 to that in 1982?
Keep it short and to the point. 0.95. What is the ratio of the Female students (as % of total students) in Barbados in 1980 to that in 1983?
Provide a succinct answer. 1.05. What is the ratio of the Female students (as % of total students) of Canada in 1980 to that in 1983?
Offer a terse response. 1.01. What is the ratio of the Female students (as % of total students) of Costa Rica in 1980 to that in 1983?
Ensure brevity in your answer.  1.01. What is the ratio of the Female students (as % of total students) in Honduras in 1980 to that in 1983?
Ensure brevity in your answer.  0.97. What is the ratio of the Female students (as % of total students) of Barbados in 1980 to that in 1984?
Offer a very short reply. 1.05. What is the ratio of the Female students (as % of total students) in Canada in 1980 to that in 1984?
Your answer should be compact. 1.02. What is the ratio of the Female students (as % of total students) of Costa Rica in 1980 to that in 1984?
Make the answer very short. 1.03. What is the ratio of the Female students (as % of total students) in Honduras in 1980 to that in 1984?
Ensure brevity in your answer.  0.94. What is the ratio of the Female students (as % of total students) in Barbados in 1980 to that in 2006?
Offer a terse response. 1.06. What is the ratio of the Female students (as % of total students) in Canada in 1980 to that in 2006?
Keep it short and to the point. 1.03. What is the ratio of the Female students (as % of total students) in Costa Rica in 1980 to that in 2006?
Offer a terse response. 1.06. What is the ratio of the Female students (as % of total students) in Honduras in 1980 to that in 2006?
Make the answer very short. 0.92. What is the ratio of the Female students (as % of total students) of Barbados in 1980 to that in 2007?
Ensure brevity in your answer.  1.06. What is the ratio of the Female students (as % of total students) in Canada in 1980 to that in 2007?
Offer a terse response. 1.03. What is the ratio of the Female students (as % of total students) in Costa Rica in 1980 to that in 2007?
Offer a terse response. 1.06. What is the ratio of the Female students (as % of total students) of Honduras in 1980 to that in 2007?
Keep it short and to the point. 0.92. What is the ratio of the Female students (as % of total students) of Barbados in 1980 to that in 2008?
Provide a succinct answer. 1.06. What is the ratio of the Female students (as % of total students) in Canada in 1980 to that in 2008?
Your response must be concise. 1.03. What is the ratio of the Female students (as % of total students) in Costa Rica in 1980 to that in 2008?
Provide a succinct answer. 1.06. What is the ratio of the Female students (as % of total students) in Honduras in 1980 to that in 2008?
Make the answer very short. 0.91. What is the ratio of the Female students (as % of total students) of Barbados in 1980 to that in 2010?
Offer a very short reply. 1.07. What is the ratio of the Female students (as % of total students) in Canada in 1980 to that in 2010?
Make the answer very short. 1.03. What is the ratio of the Female students (as % of total students) in Costa Rica in 1980 to that in 2010?
Your answer should be compact. 1.06. What is the ratio of the Female students (as % of total students) in Honduras in 1980 to that in 2010?
Provide a succinct answer. 0.93. What is the ratio of the Female students (as % of total students) in Barbados in 1982 to that in 1983?
Provide a succinct answer. 1.02. What is the ratio of the Female students (as % of total students) of Canada in 1982 to that in 1983?
Give a very brief answer. 1.01. What is the ratio of the Female students (as % of total students) of Honduras in 1982 to that in 1983?
Provide a succinct answer. 1.02. What is the ratio of the Female students (as % of total students) in Barbados in 1982 to that in 1984?
Offer a very short reply. 1.02. What is the ratio of the Female students (as % of total students) in Canada in 1982 to that in 1984?
Make the answer very short. 1.01. What is the ratio of the Female students (as % of total students) in Costa Rica in 1982 to that in 1984?
Offer a very short reply. 1.01. What is the ratio of the Female students (as % of total students) of Honduras in 1982 to that in 1984?
Ensure brevity in your answer.  0.99. What is the ratio of the Female students (as % of total students) of Barbados in 1982 to that in 2006?
Make the answer very short. 1.03. What is the ratio of the Female students (as % of total students) of Canada in 1982 to that in 2006?
Your answer should be very brief. 1.02. What is the ratio of the Female students (as % of total students) in Costa Rica in 1982 to that in 2006?
Give a very brief answer. 1.05. What is the ratio of the Female students (as % of total students) of Honduras in 1982 to that in 2006?
Make the answer very short. 0.97. What is the ratio of the Female students (as % of total students) in Barbados in 1982 to that in 2007?
Provide a short and direct response. 1.03. What is the ratio of the Female students (as % of total students) in Canada in 1982 to that in 2007?
Your answer should be compact. 1.02. What is the ratio of the Female students (as % of total students) in Costa Rica in 1982 to that in 2007?
Your response must be concise. 1.05. What is the ratio of the Female students (as % of total students) in Honduras in 1982 to that in 2007?
Provide a short and direct response. 0.97. What is the ratio of the Female students (as % of total students) of Barbados in 1982 to that in 2008?
Provide a succinct answer. 1.03. What is the ratio of the Female students (as % of total students) in Canada in 1982 to that in 2008?
Ensure brevity in your answer.  1.02. What is the ratio of the Female students (as % of total students) of Costa Rica in 1982 to that in 2008?
Your answer should be very brief. 1.05. What is the ratio of the Female students (as % of total students) of Honduras in 1982 to that in 2008?
Your answer should be compact. 0.96. What is the ratio of the Female students (as % of total students) of Barbados in 1982 to that in 2010?
Provide a succinct answer. 1.04. What is the ratio of the Female students (as % of total students) in Canada in 1982 to that in 2010?
Ensure brevity in your answer.  1.02. What is the ratio of the Female students (as % of total students) of Costa Rica in 1982 to that in 2010?
Your response must be concise. 1.05. What is the ratio of the Female students (as % of total students) in Barbados in 1983 to that in 1984?
Provide a succinct answer. 1. What is the ratio of the Female students (as % of total students) of Costa Rica in 1983 to that in 1984?
Provide a succinct answer. 1.01. What is the ratio of the Female students (as % of total students) in Honduras in 1983 to that in 1984?
Offer a very short reply. 0.97. What is the ratio of the Female students (as % of total students) of Barbados in 1983 to that in 2006?
Provide a succinct answer. 1.01. What is the ratio of the Female students (as % of total students) of Canada in 1983 to that in 2006?
Ensure brevity in your answer.  1.01. What is the ratio of the Female students (as % of total students) of Costa Rica in 1983 to that in 2006?
Your answer should be compact. 1.05. What is the ratio of the Female students (as % of total students) of Honduras in 1983 to that in 2006?
Offer a terse response. 0.95. What is the ratio of the Female students (as % of total students) of Barbados in 1983 to that in 2007?
Your answer should be very brief. 1.01. What is the ratio of the Female students (as % of total students) of Canada in 1983 to that in 2007?
Your response must be concise. 1.01. What is the ratio of the Female students (as % of total students) of Costa Rica in 1983 to that in 2007?
Give a very brief answer. 1.05. What is the ratio of the Female students (as % of total students) of Honduras in 1983 to that in 2007?
Keep it short and to the point. 0.94. What is the ratio of the Female students (as % of total students) in Barbados in 1983 to that in 2008?
Keep it short and to the point. 1.01. What is the ratio of the Female students (as % of total students) in Canada in 1983 to that in 2008?
Your answer should be very brief. 1.01. What is the ratio of the Female students (as % of total students) in Costa Rica in 1983 to that in 2008?
Give a very brief answer. 1.05. What is the ratio of the Female students (as % of total students) in Honduras in 1983 to that in 2008?
Keep it short and to the point. 0.94. What is the ratio of the Female students (as % of total students) of Barbados in 1983 to that in 2010?
Give a very brief answer. 1.02. What is the ratio of the Female students (as % of total students) of Canada in 1983 to that in 2010?
Give a very brief answer. 1.01. What is the ratio of the Female students (as % of total students) of Costa Rica in 1983 to that in 2010?
Your answer should be compact. 1.05. What is the ratio of the Female students (as % of total students) of Honduras in 1983 to that in 2010?
Keep it short and to the point. 0.96. What is the ratio of the Female students (as % of total students) in Barbados in 1984 to that in 2006?
Offer a very short reply. 1.01. What is the ratio of the Female students (as % of total students) in Canada in 1984 to that in 2006?
Ensure brevity in your answer.  1.01. What is the ratio of the Female students (as % of total students) of Costa Rica in 1984 to that in 2006?
Your answer should be compact. 1.03. What is the ratio of the Female students (as % of total students) in Honduras in 1984 to that in 2006?
Your answer should be compact. 0.98. What is the ratio of the Female students (as % of total students) of Barbados in 1984 to that in 2007?
Provide a short and direct response. 1.01. What is the ratio of the Female students (as % of total students) in Canada in 1984 to that in 2007?
Ensure brevity in your answer.  1.01. What is the ratio of the Female students (as % of total students) in Costa Rica in 1984 to that in 2007?
Give a very brief answer. 1.04. What is the ratio of the Female students (as % of total students) of Honduras in 1984 to that in 2007?
Your response must be concise. 0.98. What is the ratio of the Female students (as % of total students) in Barbados in 1984 to that in 2008?
Your answer should be compact. 1.01. What is the ratio of the Female students (as % of total students) of Canada in 1984 to that in 2008?
Your answer should be compact. 1.01. What is the ratio of the Female students (as % of total students) of Costa Rica in 1984 to that in 2008?
Ensure brevity in your answer.  1.03. What is the ratio of the Female students (as % of total students) in Honduras in 1984 to that in 2008?
Give a very brief answer. 0.97. What is the ratio of the Female students (as % of total students) in Barbados in 1984 to that in 2010?
Give a very brief answer. 1.02. What is the ratio of the Female students (as % of total students) of Canada in 1984 to that in 2010?
Your response must be concise. 1.01. What is the ratio of the Female students (as % of total students) of Costa Rica in 1984 to that in 2010?
Provide a short and direct response. 1.03. What is the ratio of the Female students (as % of total students) in Honduras in 1984 to that in 2010?
Offer a very short reply. 0.99. What is the ratio of the Female students (as % of total students) of Costa Rica in 2006 to that in 2007?
Give a very brief answer. 1.01. What is the ratio of the Female students (as % of total students) in Honduras in 2006 to that in 2007?
Offer a very short reply. 1. What is the ratio of the Female students (as % of total students) in Barbados in 2006 to that in 2008?
Keep it short and to the point. 1. What is the ratio of the Female students (as % of total students) of Costa Rica in 2006 to that in 2008?
Give a very brief answer. 1. What is the ratio of the Female students (as % of total students) in Honduras in 2006 to that in 2008?
Provide a short and direct response. 0.99. What is the ratio of the Female students (as % of total students) in Barbados in 2006 to that in 2010?
Provide a short and direct response. 1.01. What is the ratio of the Female students (as % of total students) of Canada in 2006 to that in 2010?
Keep it short and to the point. 1. What is the ratio of the Female students (as % of total students) in Costa Rica in 2006 to that in 2010?
Offer a terse response. 1. What is the ratio of the Female students (as % of total students) in Honduras in 2006 to that in 2010?
Offer a terse response. 1.01. What is the ratio of the Female students (as % of total students) in Canada in 2007 to that in 2008?
Your answer should be compact. 1. What is the ratio of the Female students (as % of total students) in Costa Rica in 2007 to that in 2008?
Your answer should be compact. 1. What is the ratio of the Female students (as % of total students) of Honduras in 2007 to that in 2008?
Offer a very short reply. 0.99. What is the ratio of the Female students (as % of total students) in Barbados in 2007 to that in 2010?
Your response must be concise. 1.01. What is the ratio of the Female students (as % of total students) in Barbados in 2008 to that in 2010?
Your answer should be very brief. 1.01. What is the ratio of the Female students (as % of total students) of Honduras in 2008 to that in 2010?
Make the answer very short. 1.02. What is the difference between the highest and the second highest Female students (as % of total students) of Barbados?
Your answer should be compact. 1.61. What is the difference between the highest and the second highest Female students (as % of total students) in Canada?
Your answer should be compact. 0.37. What is the difference between the highest and the second highest Female students (as % of total students) of Costa Rica?
Make the answer very short. 0.58. What is the difference between the highest and the second highest Female students (as % of total students) in Honduras?
Give a very brief answer. 0.3. What is the difference between the highest and the lowest Female students (as % of total students) of Barbados?
Your answer should be compact. 3.59. What is the difference between the highest and the lowest Female students (as % of total students) in Canada?
Give a very brief answer. 1.32. What is the difference between the highest and the lowest Female students (as % of total students) in Costa Rica?
Your answer should be very brief. 3.21. What is the difference between the highest and the lowest Female students (as % of total students) in Honduras?
Offer a very short reply. 4.85. 